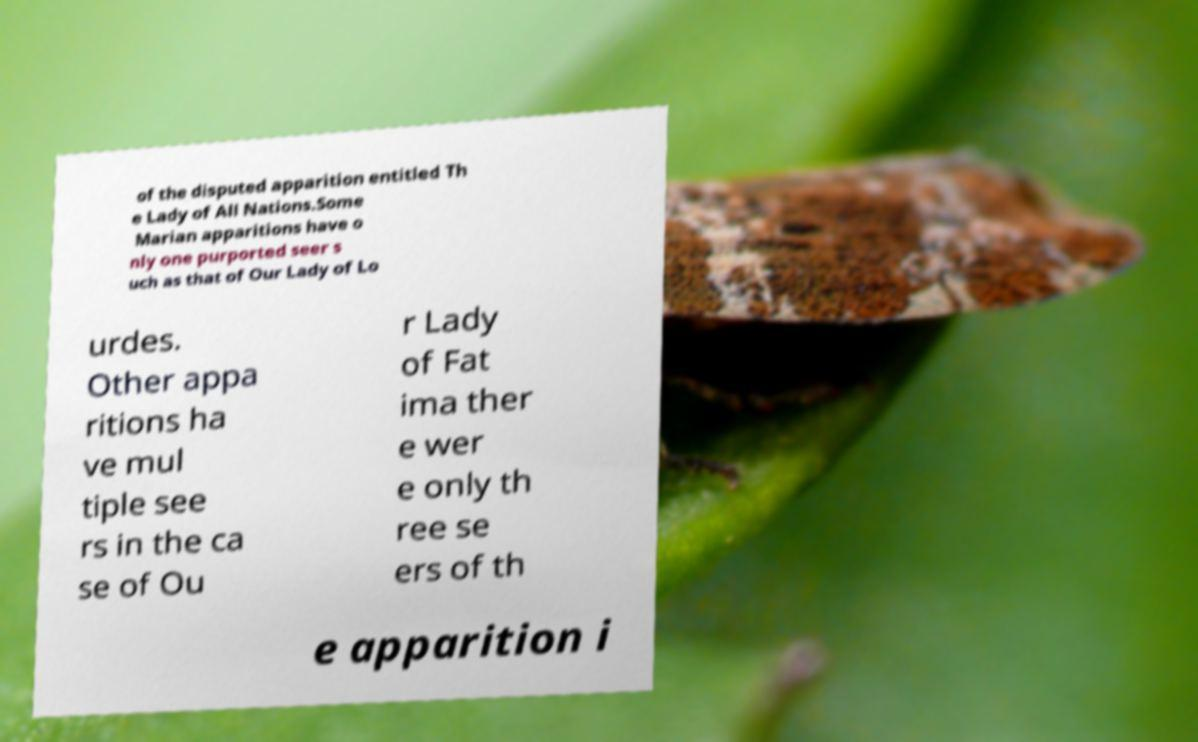For documentation purposes, I need the text within this image transcribed. Could you provide that? of the disputed apparition entitled Th e Lady of All Nations.Some Marian apparitions have o nly one purported seer s uch as that of Our Lady of Lo urdes. Other appa ritions ha ve mul tiple see rs in the ca se of Ou r Lady of Fat ima ther e wer e only th ree se ers of th e apparition i 